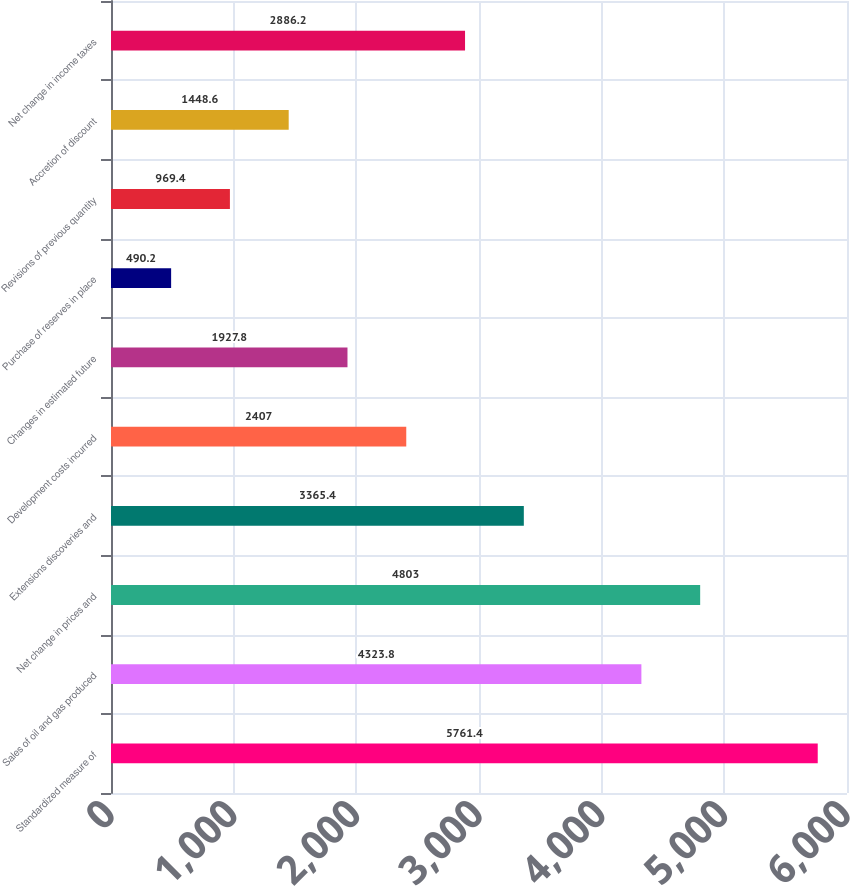Convert chart to OTSL. <chart><loc_0><loc_0><loc_500><loc_500><bar_chart><fcel>Standardized measure of<fcel>Sales of oil and gas produced<fcel>Net change in prices and<fcel>Extensions discoveries and<fcel>Development costs incurred<fcel>Changes in estimated future<fcel>Purchase of reserves in place<fcel>Revisions of previous quantity<fcel>Accretion of discount<fcel>Net change in income taxes<nl><fcel>5761.4<fcel>4323.8<fcel>4803<fcel>3365.4<fcel>2407<fcel>1927.8<fcel>490.2<fcel>969.4<fcel>1448.6<fcel>2886.2<nl></chart> 